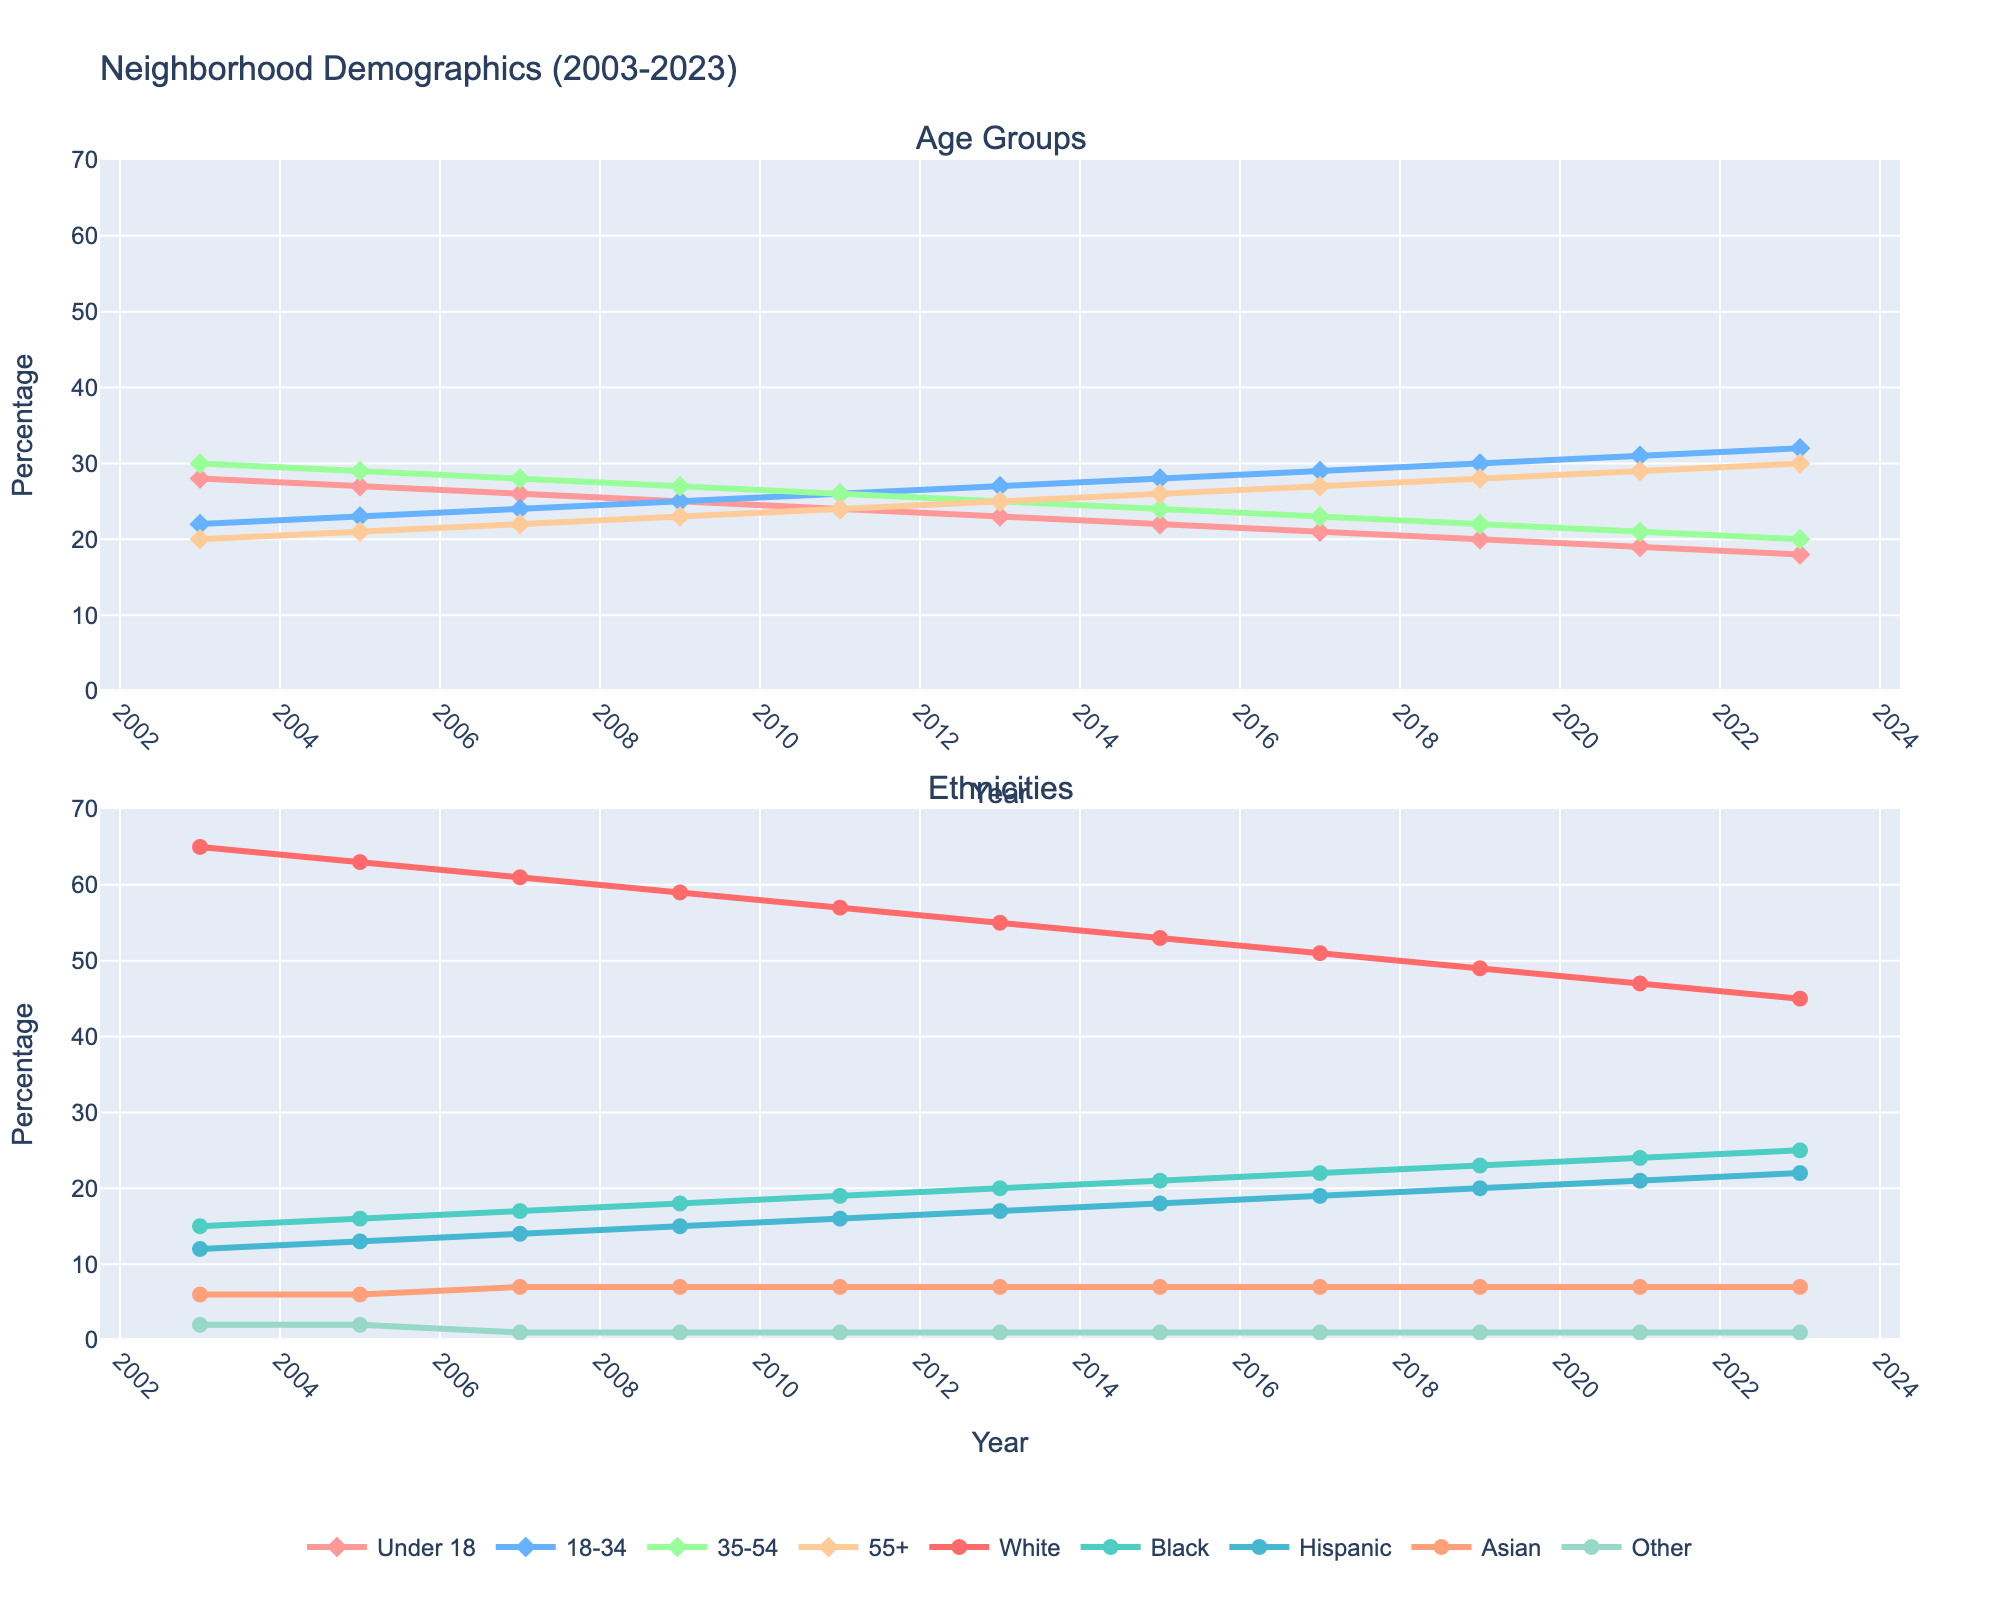What is the overall trend in the percentage of the 'Under 18' age group from 2003 to 2023? Looking at the first subplot, the line representing the 'Under 18' age group consistently decreases from 28% in 2003 to 18% in 2023.
Answer: Decreasing Which ethnic group had the most significant increase in percentage from 2003 to 2023? By examining the second subplot, the 'Hispanic' group increases from 12% in 2003 to 22% in 2023, showing the most significant increase among all ethnic groups.
Answer: Hispanic How does the percentage of the 'White' ethnic group in 2023 compare to that in 2003? Viewing the second subplot, the 'White' group's line shows a decrease from 65% in 2003 to 45% in 2023. This means the percentage decreased by 20%.
Answer: Decreased by 20% What is the sum of the percentages of the '18-34' and '55+' age groups in 2023? In the first subplot, '18-34' has 32% and '55+' has 30% in 2023. Adding them together results in 32% + 30% = 62%.
Answer: 62% Which year marks the point when the '18-34' age group surpasses the '35-54' age group in percentage? Focusing on the first subplot, the '18-34' group's line surpasses the '35-54' group's line between 2011 and 2013 as '18-34' increases to 26% while '35-54' decreases to 25% in 2013.
Answer: 2013 What is the percentage difference between the 'Black' and 'Asian' ethnic groups in 2023? In the second subplot, for 2023, 'Black' is at 25% and 'Asian' is at 7%. The difference is 25% - 7% = 18%.
Answer: 18% Between 2013 and 2015, which age group showed the highest increase in percentage, and by how much? In the first subplot, the '55+' age group increases from 25% in 2013 to 26% in 2015, a 1% increase. All other age groups either decrease or stay the same.
Answer: '55+', 1% In 2009, what is the combined percentage of the 'White' and 'Hispanic' ethnic groups? Referring to the second subplot, in 2009, 'White' is 59% and 'Hispanic' is 15%. Combined, they sum to 59% + 15% = 74%.
Answer: 74% Which ethnicity's percentage remained constant from 2007 to 2023? Observing the second subplot, the 'Asian' ethnic group's line remains constant at 7% throughout this period.
Answer: Asian What is the average percentage of the '35-54' age group across the 20 years? The percentages for '35-54' are 30, 29, 28, 27, 26, 25, 24, 23, 22, 21, and 20 across 2003 to 2023, respectively. Sum these (30+29+28+27+26+25+24+23+22+21+20) = 275, so average = 275/11 ≈ 25.
Answer: 25 